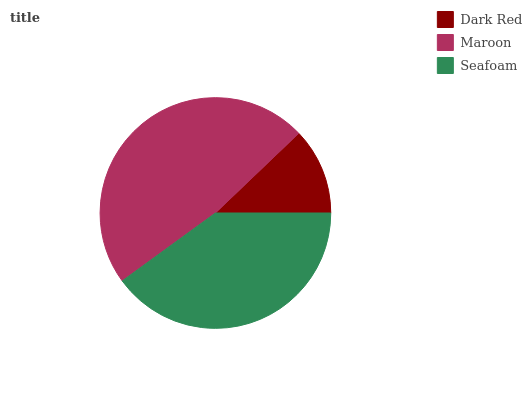Is Dark Red the minimum?
Answer yes or no. Yes. Is Maroon the maximum?
Answer yes or no. Yes. Is Seafoam the minimum?
Answer yes or no. No. Is Seafoam the maximum?
Answer yes or no. No. Is Maroon greater than Seafoam?
Answer yes or no. Yes. Is Seafoam less than Maroon?
Answer yes or no. Yes. Is Seafoam greater than Maroon?
Answer yes or no. No. Is Maroon less than Seafoam?
Answer yes or no. No. Is Seafoam the high median?
Answer yes or no. Yes. Is Seafoam the low median?
Answer yes or no. Yes. Is Maroon the high median?
Answer yes or no. No. Is Maroon the low median?
Answer yes or no. No. 